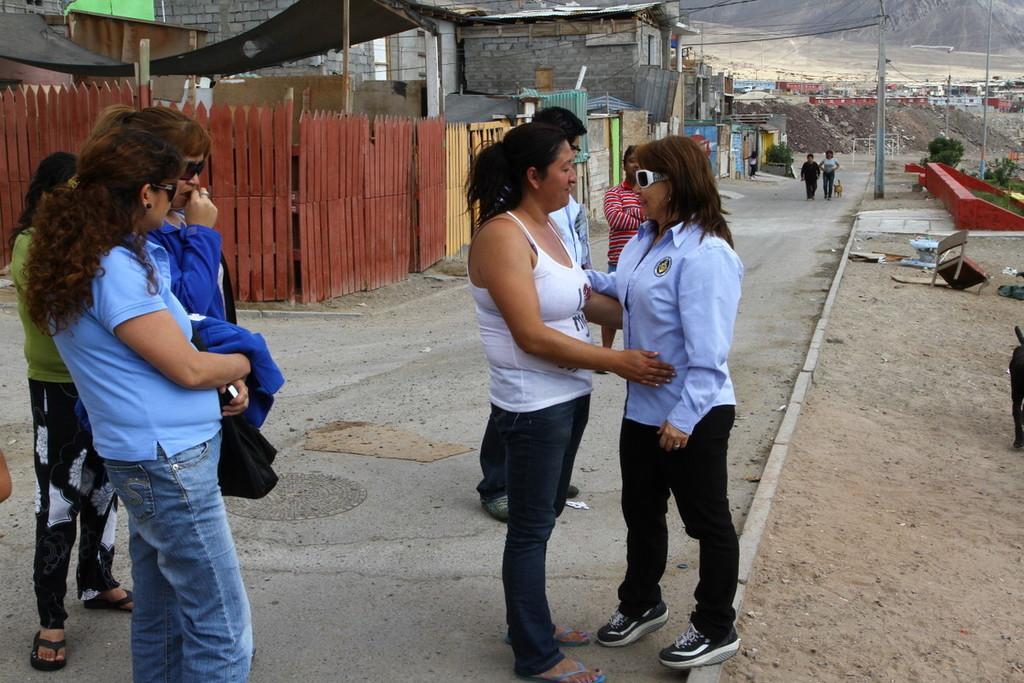In one or two sentences, can you explain what this image depicts? In the image there are few people standing in the foreground and around them there are different objects and on the left side there is a fencing, behind the fencing there are houses and in the background there is an open land and behind that there is a mountain. 